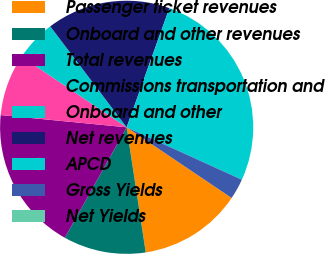Convert chart. <chart><loc_0><loc_0><loc_500><loc_500><pie_chart><fcel>Passenger ticket revenues<fcel>Onboard and other revenues<fcel>Total revenues<fcel>Commissions transportation and<fcel>Onboard and other<fcel>Net revenues<fcel>APCD<fcel>Gross Yields<fcel>Net Yields<nl><fcel>13.16%<fcel>10.53%<fcel>18.42%<fcel>7.89%<fcel>5.26%<fcel>15.79%<fcel>26.32%<fcel>2.63%<fcel>0.0%<nl></chart> 